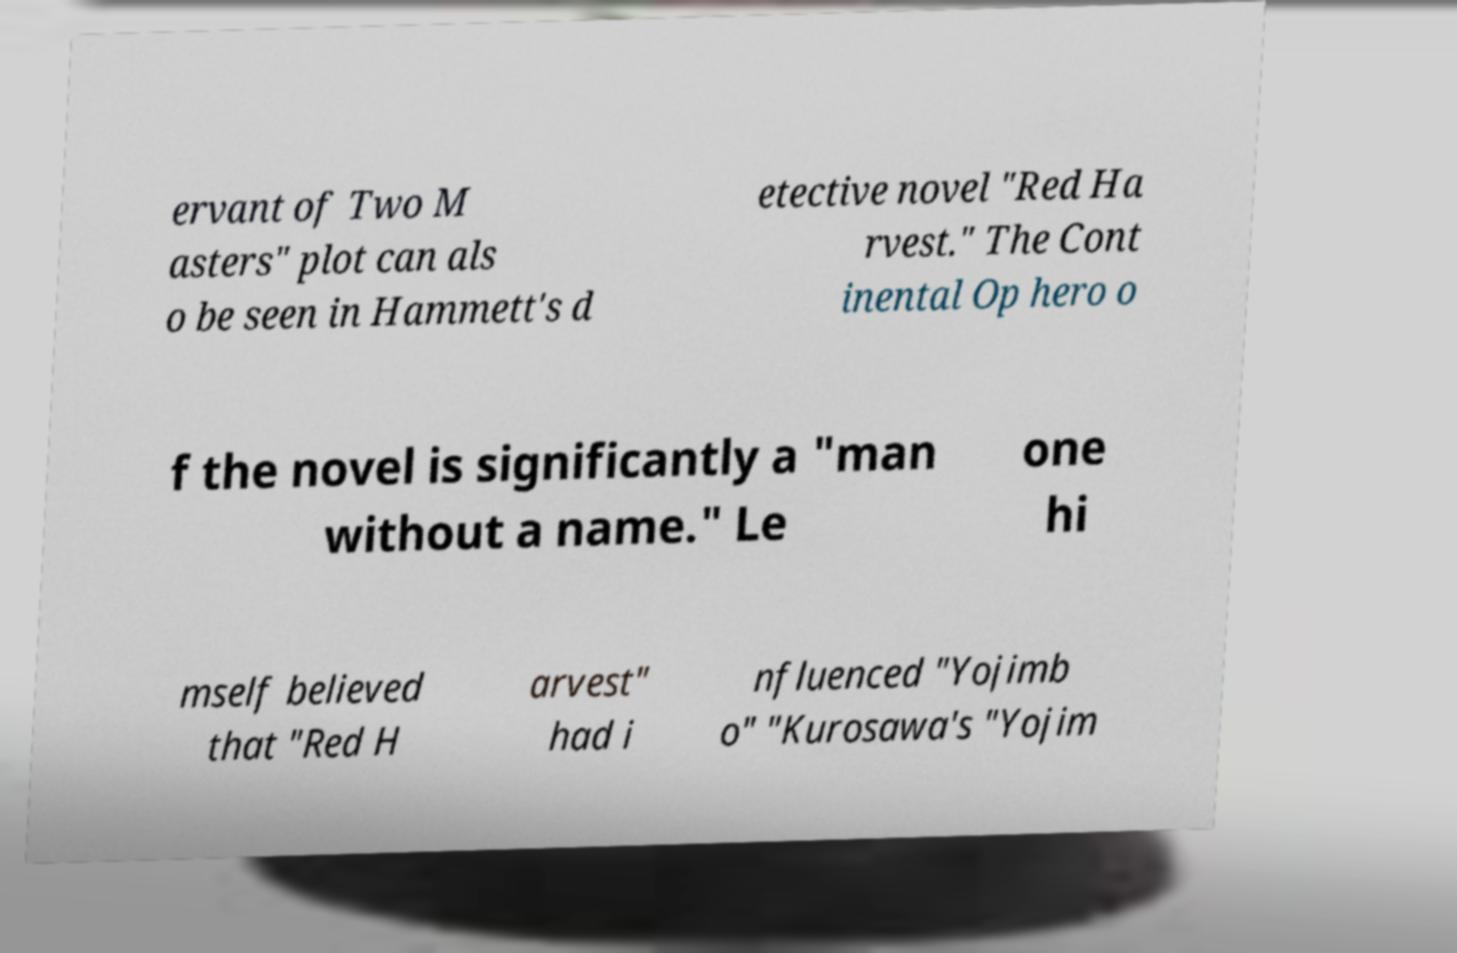Please identify and transcribe the text found in this image. ervant of Two M asters" plot can als o be seen in Hammett's d etective novel "Red Ha rvest." The Cont inental Op hero o f the novel is significantly a "man without a name." Le one hi mself believed that "Red H arvest" had i nfluenced "Yojimb o" "Kurosawa's "Yojim 